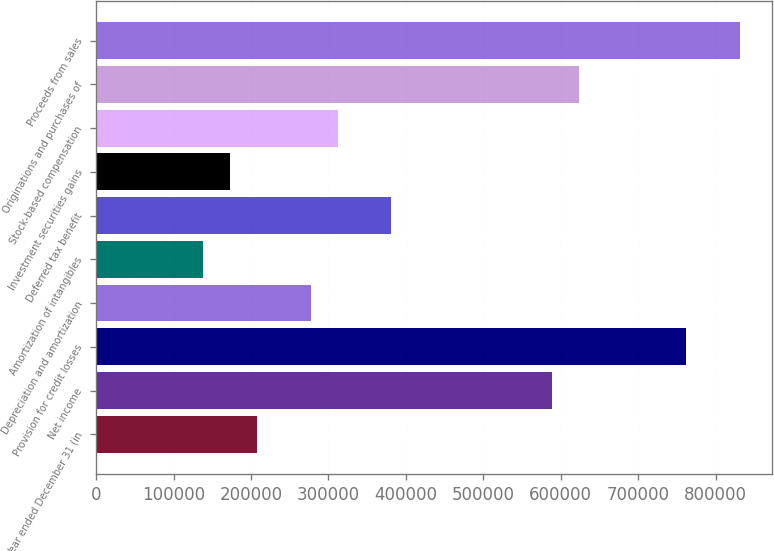Convert chart. <chart><loc_0><loc_0><loc_500><loc_500><bar_chart><fcel>Year ended December 31 (in<fcel>Net income<fcel>Provision for credit losses<fcel>Depreciation and amortization<fcel>Amortization of intangibles<fcel>Deferred tax benefit<fcel>Investment securities gains<fcel>Stock-based compensation<fcel>Originations and purchases of<fcel>Proceeds from sales<nl><fcel>207827<fcel>588826<fcel>762008<fcel>277099<fcel>138554<fcel>381008<fcel>173190<fcel>311736<fcel>623462<fcel>831280<nl></chart> 